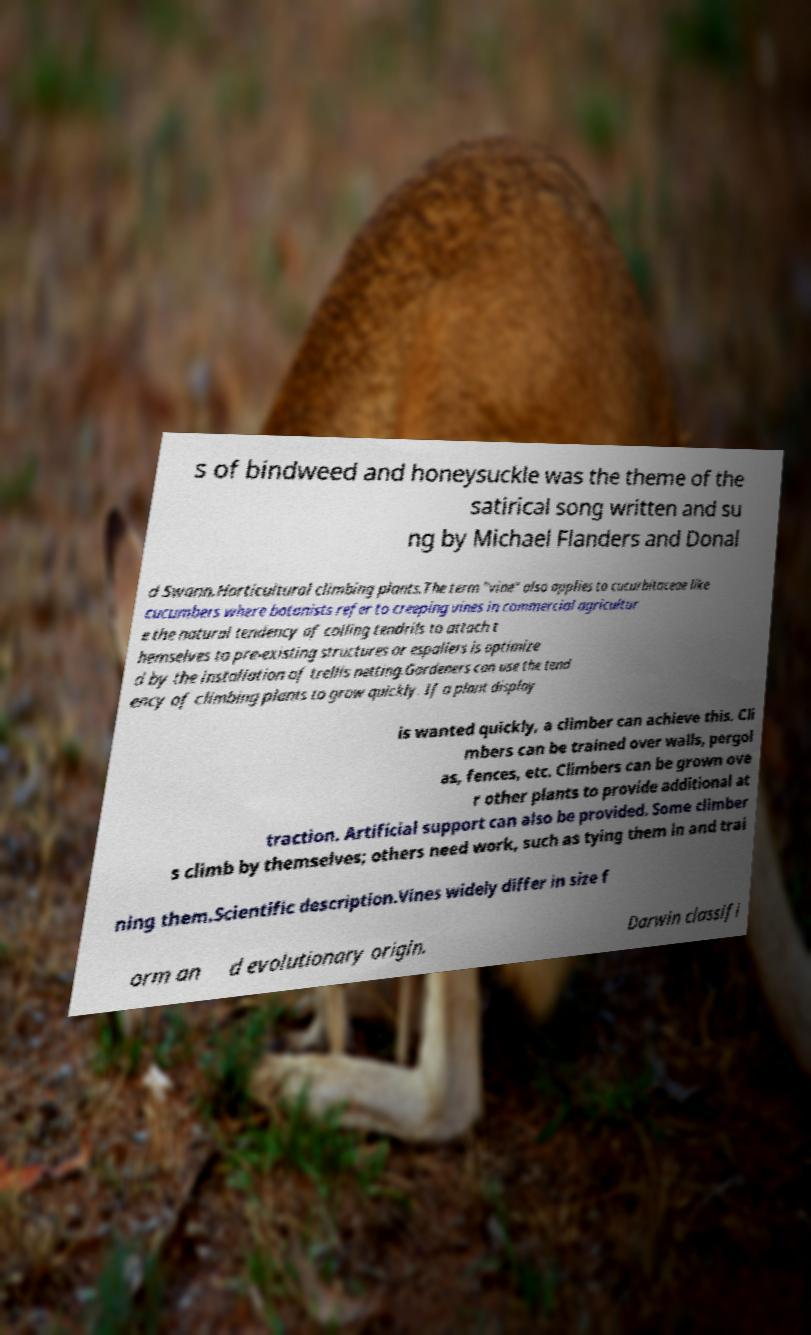Please read and relay the text visible in this image. What does it say? s of bindweed and honeysuckle was the theme of the satirical song written and su ng by Michael Flanders and Donal d Swann.Horticultural climbing plants.The term "vine" also applies to cucurbitaceae like cucumbers where botanists refer to creeping vines in commercial agricultur e the natural tendency of coiling tendrils to attach t hemselves to pre-existing structures or espaliers is optimize d by the installation of trellis netting.Gardeners can use the tend ency of climbing plants to grow quickly. If a plant display is wanted quickly, a climber can achieve this. Cli mbers can be trained over walls, pergol as, fences, etc. Climbers can be grown ove r other plants to provide additional at traction. Artificial support can also be provided. Some climber s climb by themselves; others need work, such as tying them in and trai ning them.Scientific description.Vines widely differ in size f orm an d evolutionary origin. Darwin classifi 